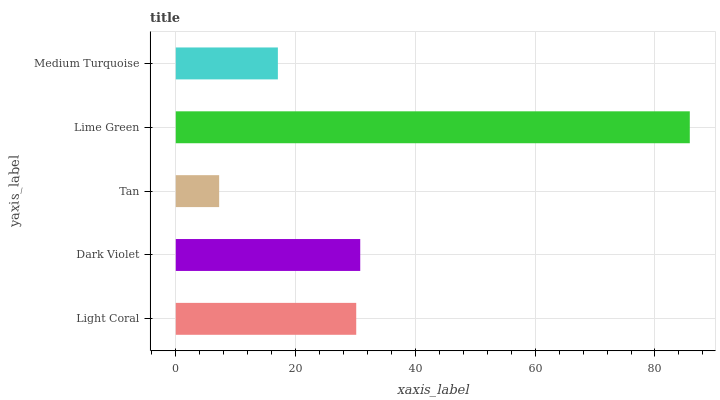Is Tan the minimum?
Answer yes or no. Yes. Is Lime Green the maximum?
Answer yes or no. Yes. Is Dark Violet the minimum?
Answer yes or no. No. Is Dark Violet the maximum?
Answer yes or no. No. Is Dark Violet greater than Light Coral?
Answer yes or no. Yes. Is Light Coral less than Dark Violet?
Answer yes or no. Yes. Is Light Coral greater than Dark Violet?
Answer yes or no. No. Is Dark Violet less than Light Coral?
Answer yes or no. No. Is Light Coral the high median?
Answer yes or no. Yes. Is Light Coral the low median?
Answer yes or no. Yes. Is Lime Green the high median?
Answer yes or no. No. Is Tan the low median?
Answer yes or no. No. 